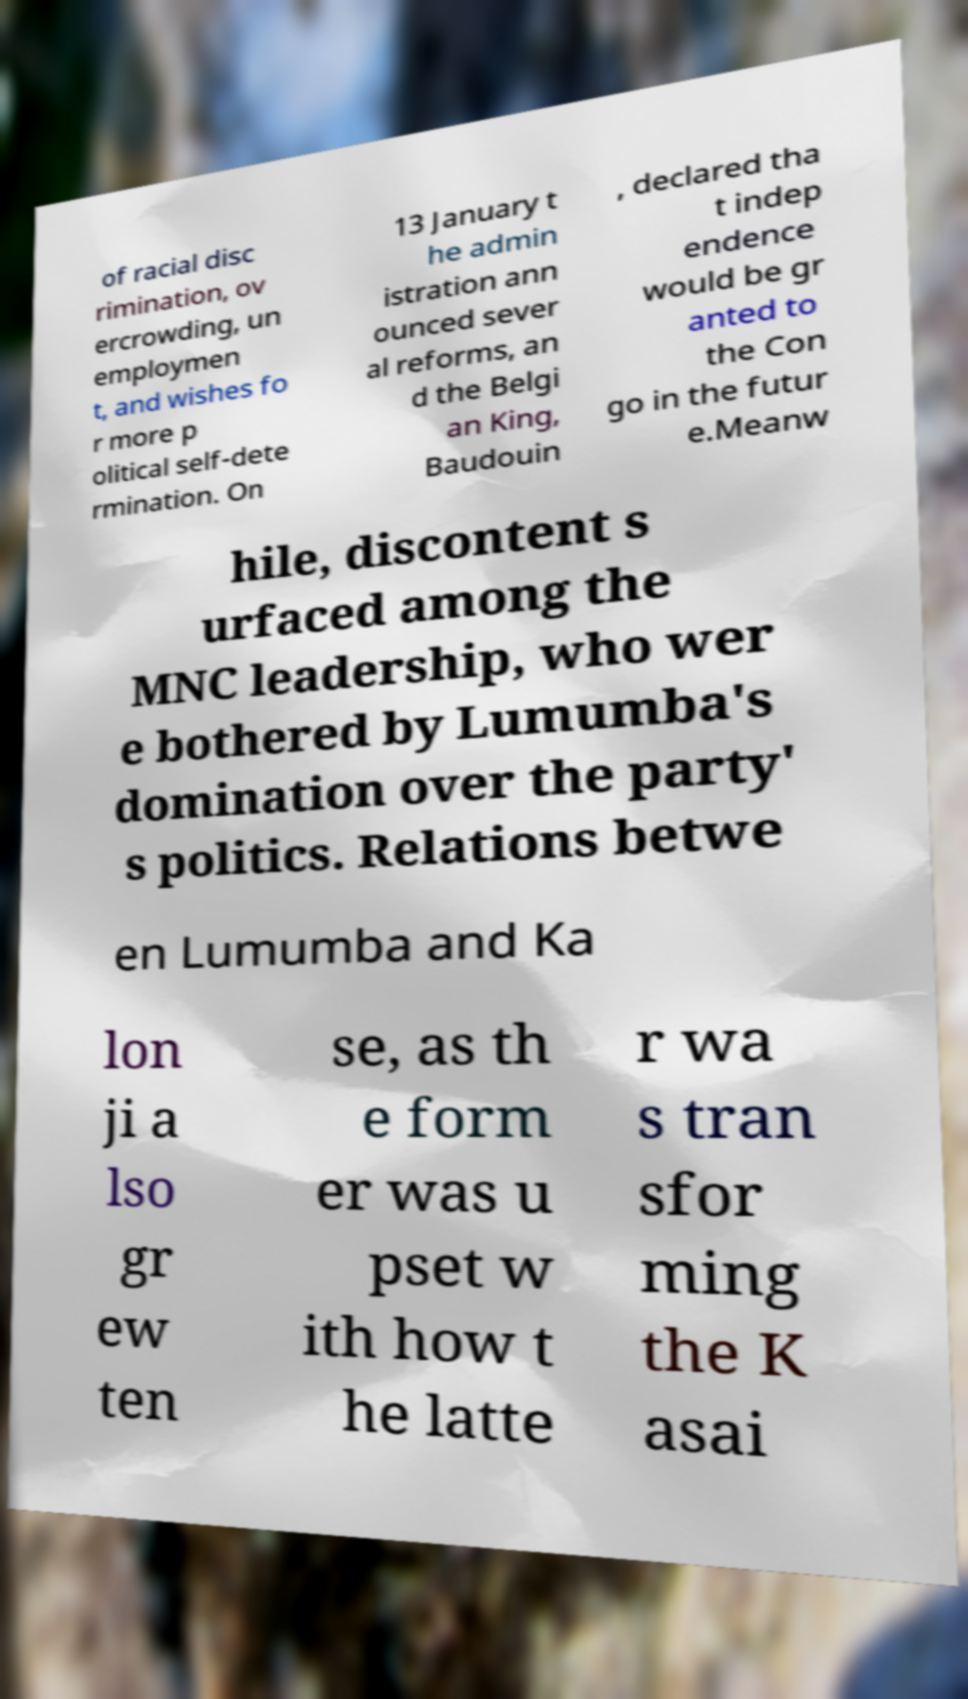Please read and relay the text visible in this image. What does it say? of racial disc rimination, ov ercrowding, un employmen t, and wishes fo r more p olitical self-dete rmination. On 13 January t he admin istration ann ounced sever al reforms, an d the Belgi an King, Baudouin , declared tha t indep endence would be gr anted to the Con go in the futur e.Meanw hile, discontent s urfaced among the MNC leadership, who wer e bothered by Lumumba's domination over the party' s politics. Relations betwe en Lumumba and Ka lon ji a lso gr ew ten se, as th e form er was u pset w ith how t he latte r wa s tran sfor ming the K asai 